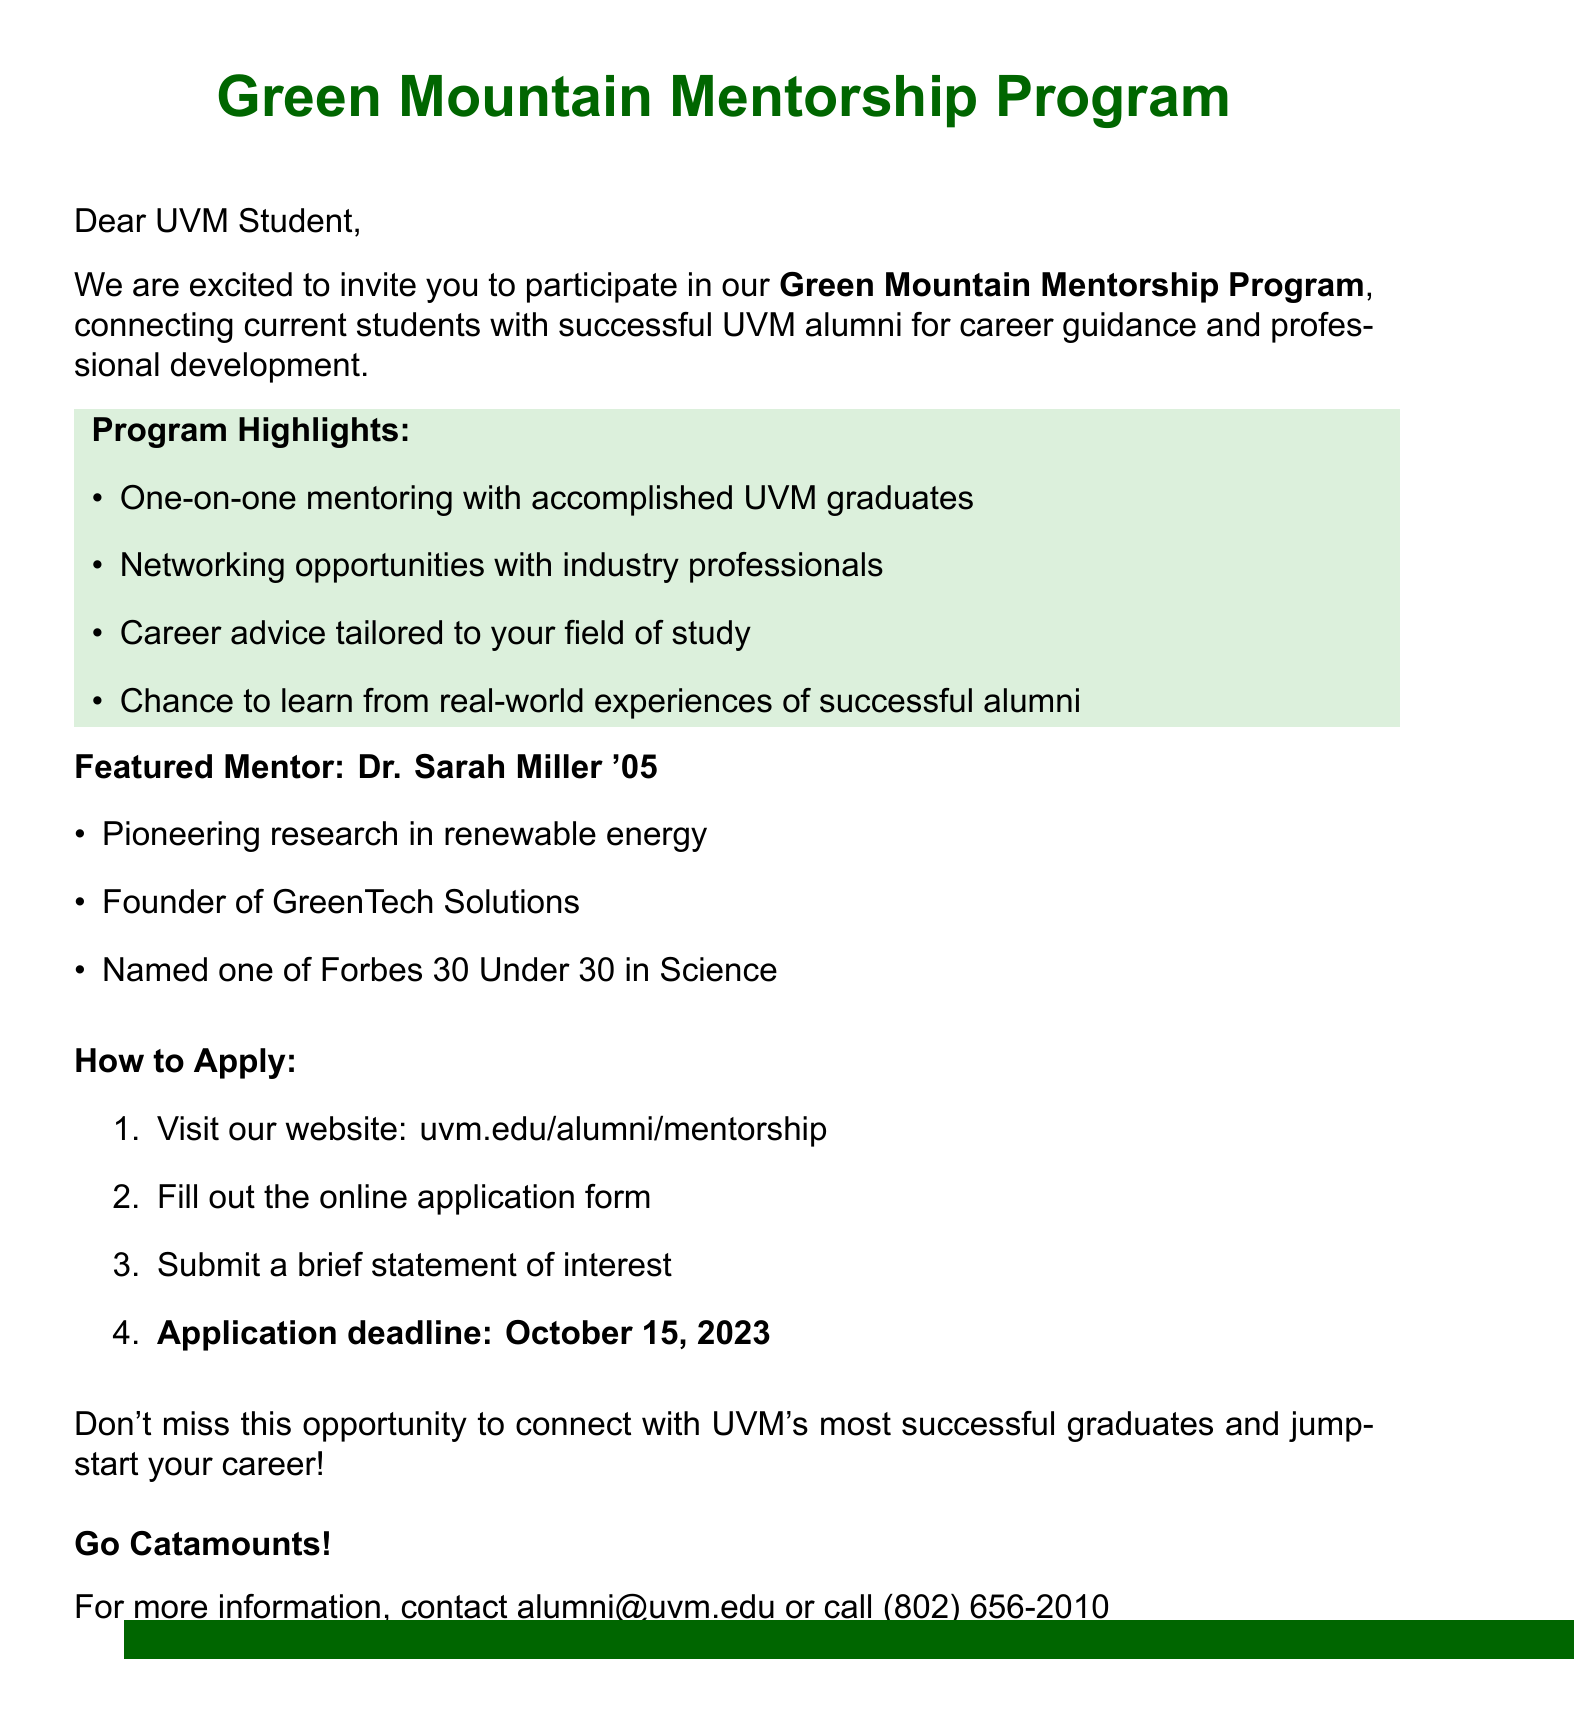What is the name of the mentorship program? The name of the mentorship program is highlighted in the introduction section of the document as "Green Mountain Mentorship Program."
Answer: Green Mountain Mentorship Program Who is the featured mentor mentioned in the document? The document provides the name of the featured mentor, Dr. Sarah Miller, in the section "Featured Mentor."
Answer: Dr. Sarah Miller '05 What year did Dr. Sarah Miller graduate? Dr. Sarah Miller's graduation year is included in her title as '05, indicating the year of completion.
Answer: '05 What is one of Dr. Miller's accomplishments? The document lists her accomplishments; one is pioneering research in renewable energy, found in the "Featured Mentor" section.
Answer: Pioneering research in renewable energy What is the application deadline for the mentorship program? The application deadline is specified in the "How to Apply" section of the document.
Answer: October 15, 2023 What should students submit along with the application form? The document states one requirement is to submit a brief statement of interest with the application form in the "How to Apply" section.
Answer: Brief statement of interest How can students apply for the program? The application process is detailed in the "How to Apply" section, starting with visiting the website.
Answer: Visit our website: uvm.edu/alumni/mentorship What is the main purpose of the Green Mountain Mentorship Program? The purpose of the program is described early in the document as connecting current students with successful UVM alumni for career guidance and professional development.
Answer: Connecting current students with successful UVM alumni for career guidance and professional development 